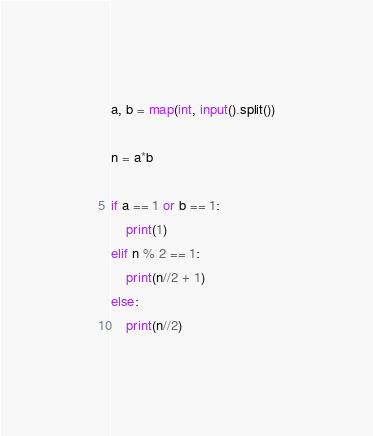Convert code to text. <code><loc_0><loc_0><loc_500><loc_500><_Python_>a, b = map(int, input().split())

n = a*b

if a == 1 or b == 1:
    print(1)
elif n % 2 == 1:
    print(n//2 + 1)
else:
    print(n//2)</code> 